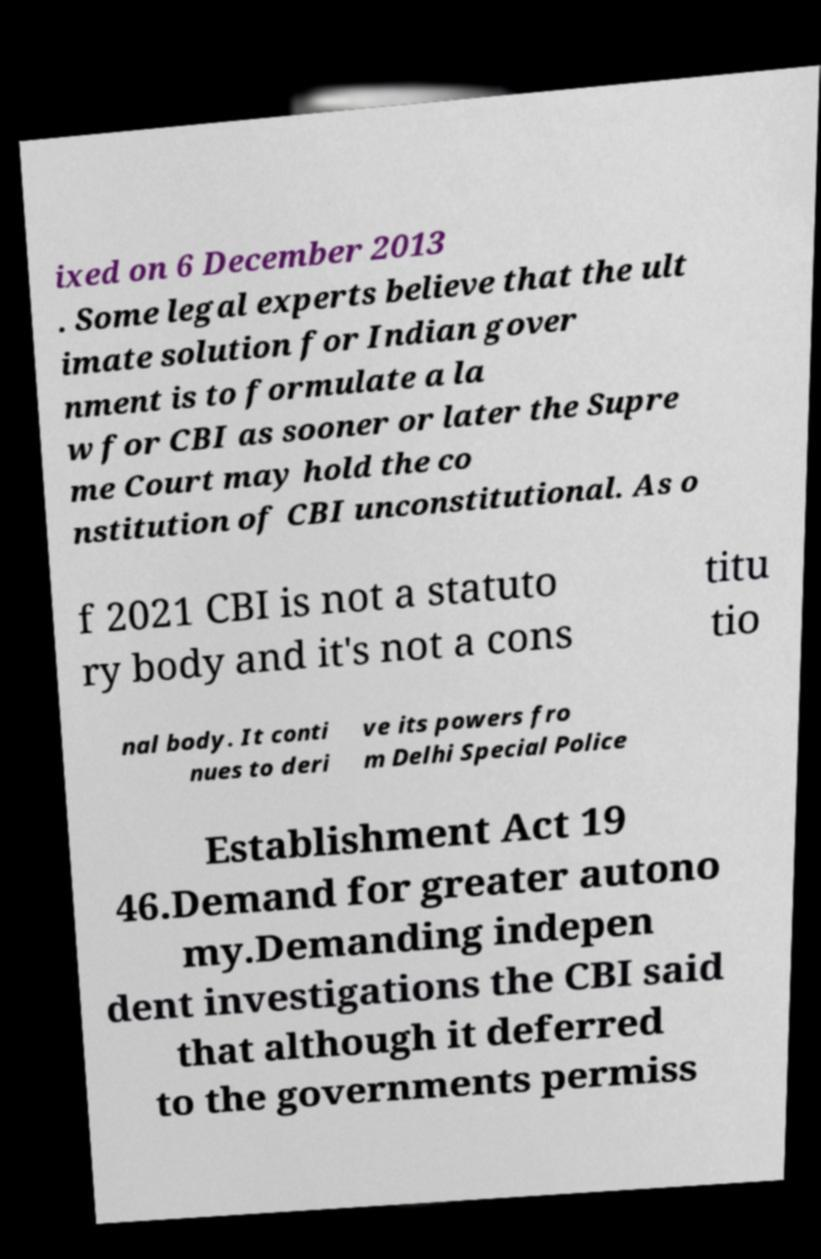Can you accurately transcribe the text from the provided image for me? ixed on 6 December 2013 . Some legal experts believe that the ult imate solution for Indian gover nment is to formulate a la w for CBI as sooner or later the Supre me Court may hold the co nstitution of CBI unconstitutional. As o f 2021 CBI is not a statuto ry body and it's not a cons titu tio nal body. It conti nues to deri ve its powers fro m Delhi Special Police Establishment Act 19 46.Demand for greater autono my.Demanding indepen dent investigations the CBI said that although it deferred to the governments permiss 